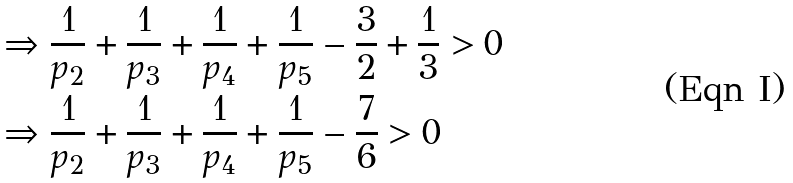<formula> <loc_0><loc_0><loc_500><loc_500>& \Rightarrow \frac { 1 } { p _ { 2 } } + \frac { 1 } { p _ { 3 } } + \frac { 1 } { p _ { 4 } } + \frac { 1 } { p _ { 5 } } - \frac { 3 } { 2 } + \frac { 1 } { 3 } > 0 \\ & \Rightarrow \frac { 1 } { p _ { 2 } } + \frac { 1 } { p _ { 3 } } + \frac { 1 } { p _ { 4 } } + \frac { 1 } { p _ { 5 } } - \frac { 7 } { 6 } > 0</formula> 